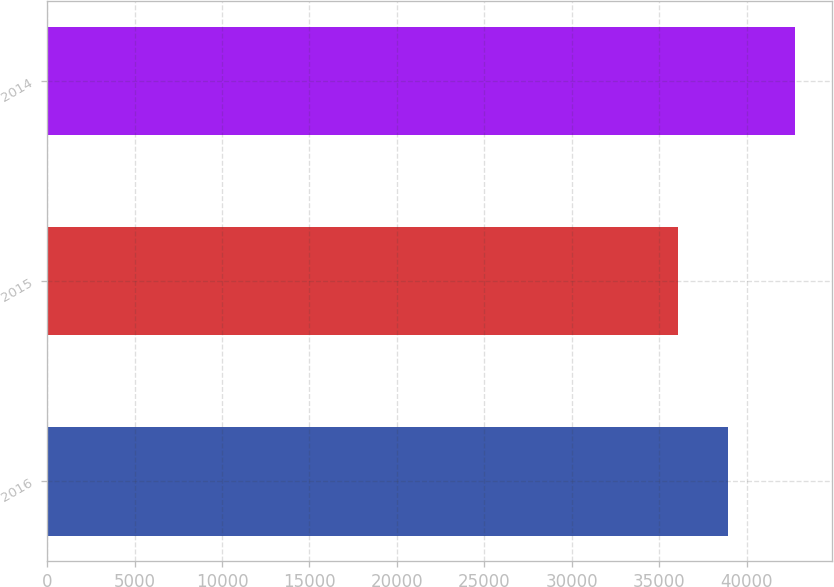Convert chart to OTSL. <chart><loc_0><loc_0><loc_500><loc_500><bar_chart><fcel>2016<fcel>2015<fcel>2014<nl><fcel>38960<fcel>36074<fcel>42765<nl></chart> 